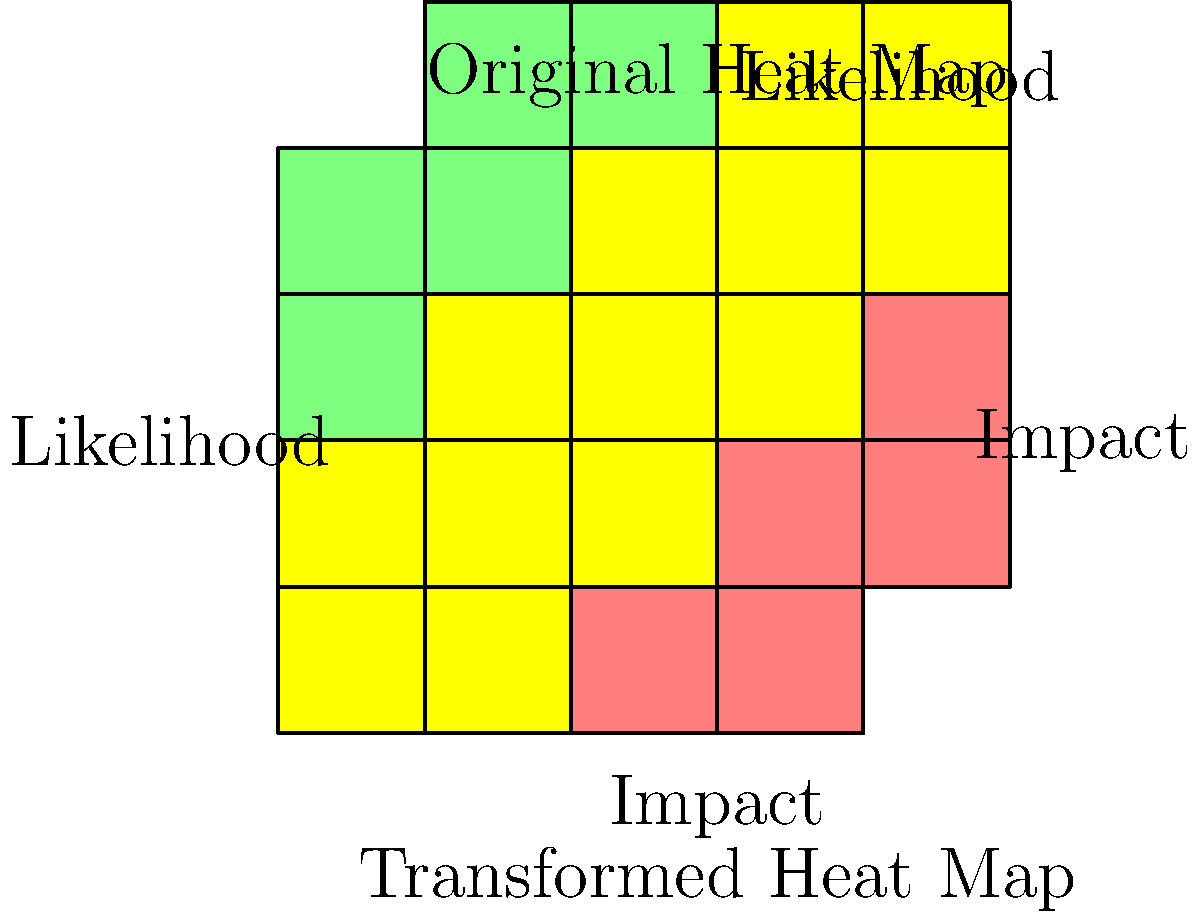A business impact analysis heat map is subjected to a series of transformations. First, it is reflected over the horizontal line $y=-2$, and then rotated 90° clockwise around the point (2, -2). Given the original heat map shown in the upper part of the image, which of the following statements accurately describes the transformation of the high-risk area (red cells) in the resulting heat map?

A) The high-risk area moves from the upper-right to the lower-left corner.
B) The high-risk area moves from the upper-right to the upper-left corner.
C) The high-risk area remains in the upper-right corner but is rotated.
D) The high-risk area is split into two separate regions. Let's analyze this transformation step-by-step:

1) The original heat map has the high-risk area (red cells) in the upper-right corner.

2) The first transformation is a reflection over the line $y=-2$. This horizontal line passes through the middle of the heat map.
   - This reflection will flip the heat map vertically, moving the high-risk area from the upper-right to the lower-right corner.

3) The second transformation is a 90° clockwise rotation around the point (2, -2). This point is at the center of the heat map.
   - A 90° clockwise rotation will move the lower-right corner to the lower-left corner.

4) Combining these transformations:
   - The high-risk area starts in the upper-right corner.
   - After reflection, it moves to the lower-right corner.
   - After rotation, it ends up in the lower-left corner.

5) Looking at the transformed heat map in the lower part of the image, we can confirm that the high-risk area (red cells) is indeed in the lower-left corner.

Therefore, the correct statement is that the high-risk area moves from the upper-right to the lower-left corner.
Answer: A 